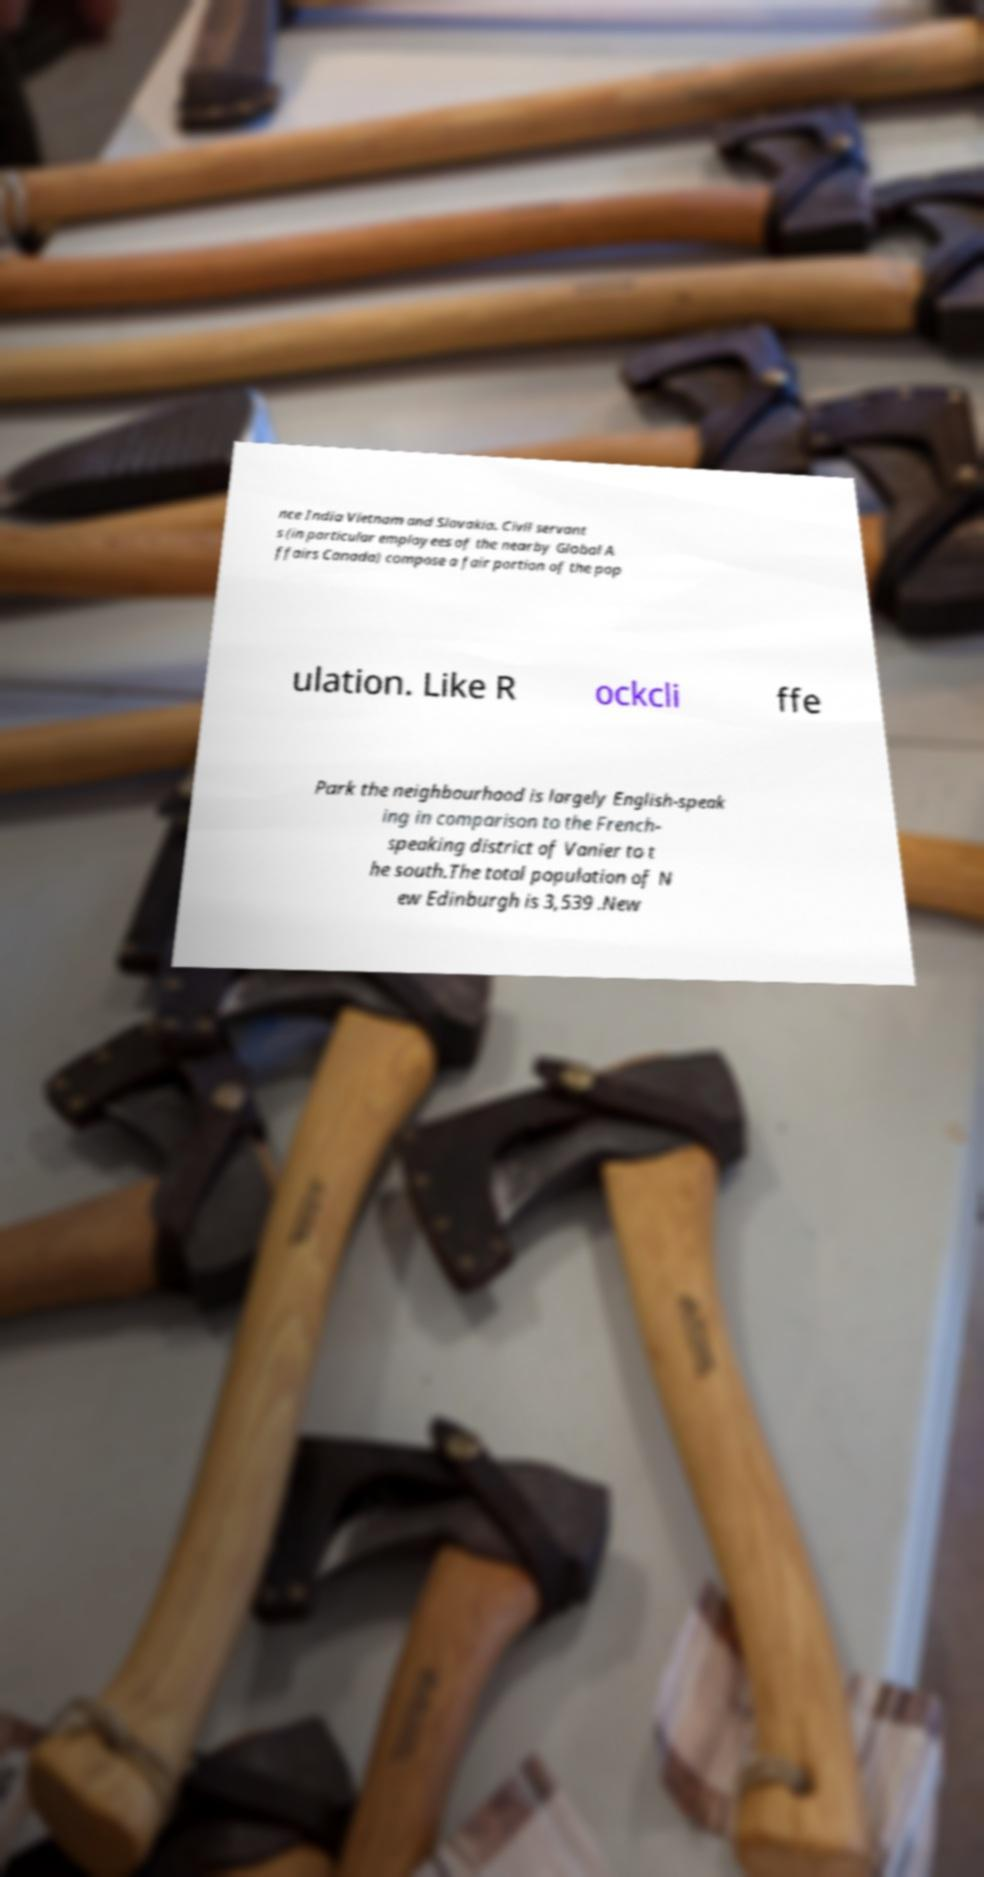There's text embedded in this image that I need extracted. Can you transcribe it verbatim? nce India Vietnam and Slovakia. Civil servant s (in particular employees of the nearby Global A ffairs Canada) compose a fair portion of the pop ulation. Like R ockcli ffe Park the neighbourhood is largely English-speak ing in comparison to the French- speaking district of Vanier to t he south.The total population of N ew Edinburgh is 3,539 .New 